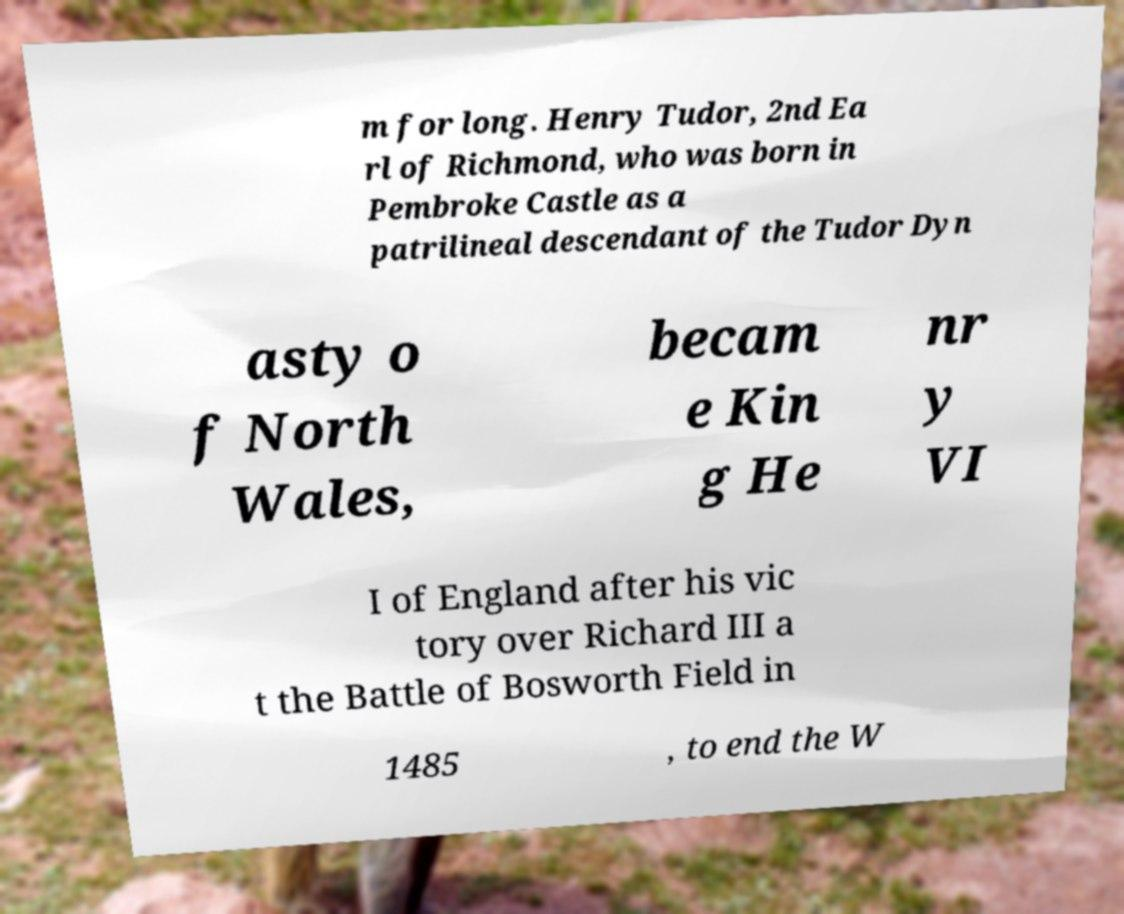For documentation purposes, I need the text within this image transcribed. Could you provide that? m for long. Henry Tudor, 2nd Ea rl of Richmond, who was born in Pembroke Castle as a patrilineal descendant of the Tudor Dyn asty o f North Wales, becam e Kin g He nr y VI I of England after his vic tory over Richard III a t the Battle of Bosworth Field in 1485 , to end the W 